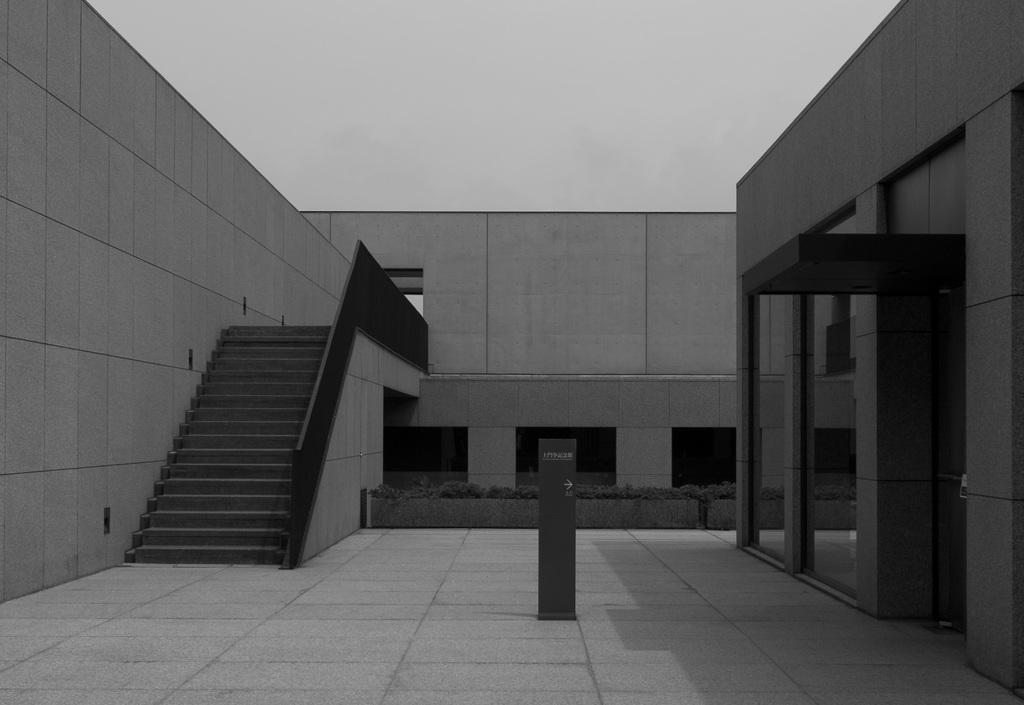Could you give a brief overview of what you see in this image? In this image I can see on the left side it is a staircase. On the right side there are glass walls. It is a construction, at the top it is the sky. 